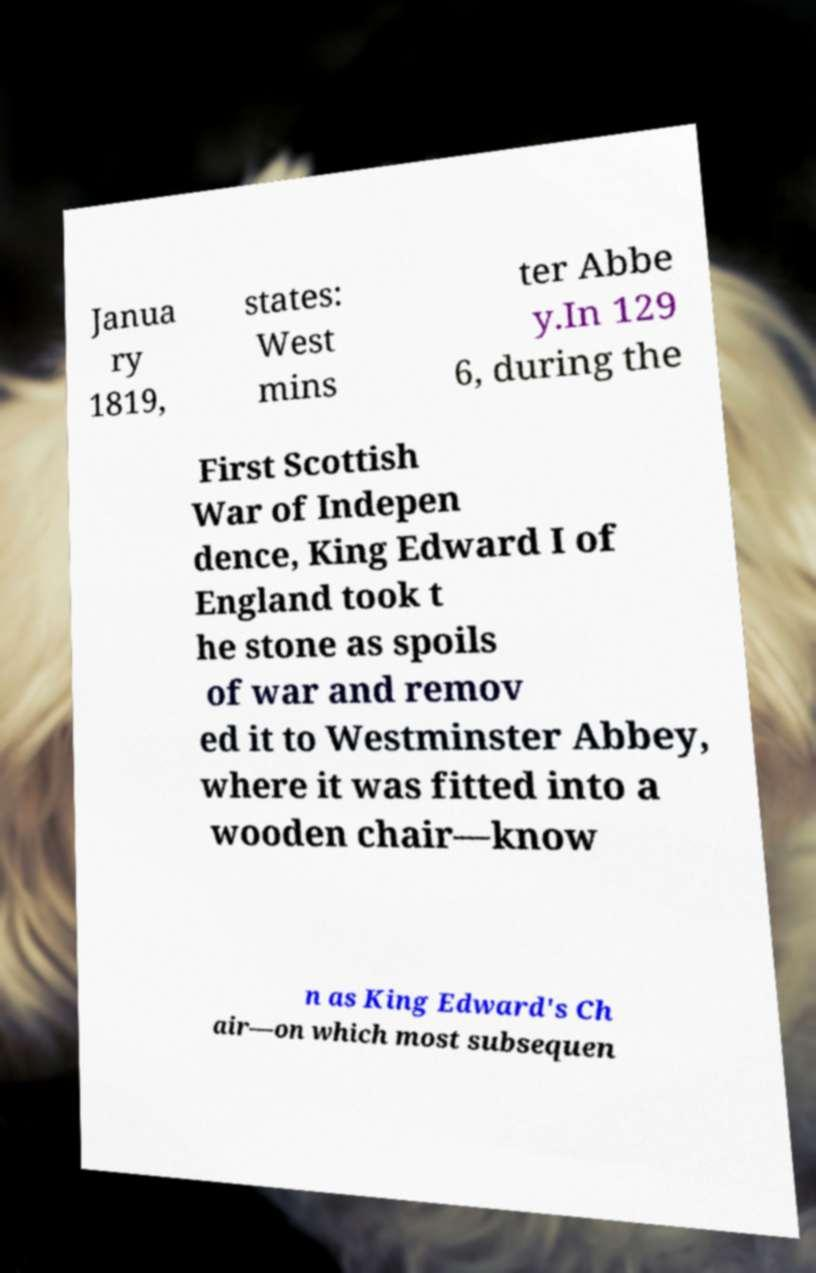Please identify and transcribe the text found in this image. Janua ry 1819, states: West mins ter Abbe y.In 129 6, during the First Scottish War of Indepen dence, King Edward I of England took t he stone as spoils of war and remov ed it to Westminster Abbey, where it was fitted into a wooden chair—know n as King Edward's Ch air—on which most subsequen 